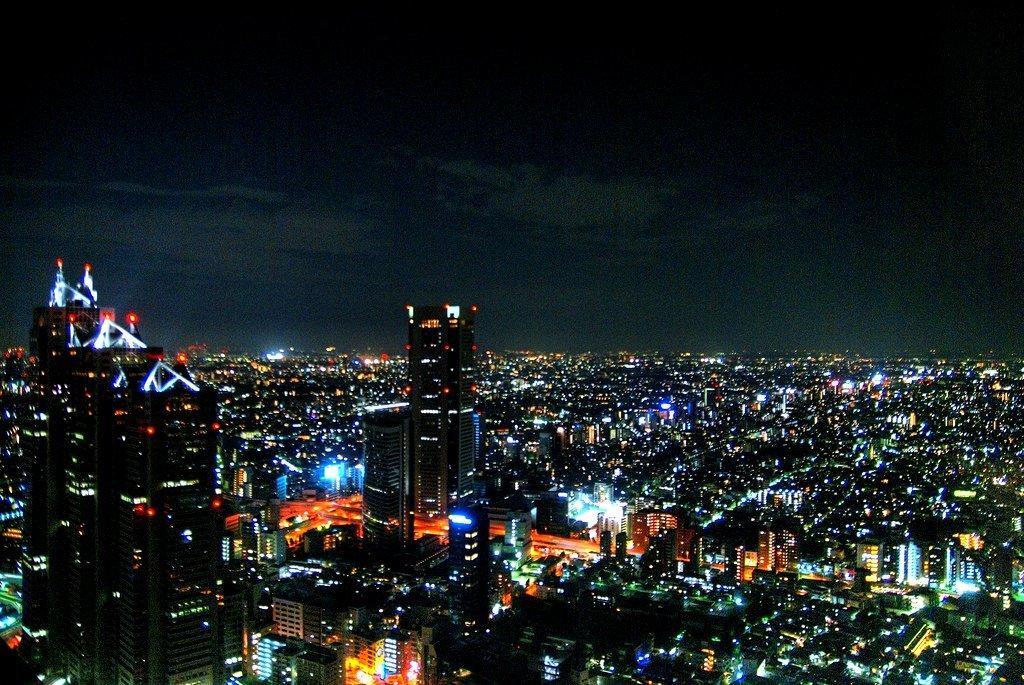Can you describe this image briefly? In this image at the bottom there are buildings, skyscrapers and there is a walkway and some lights. And at the top of the image there is sky. 